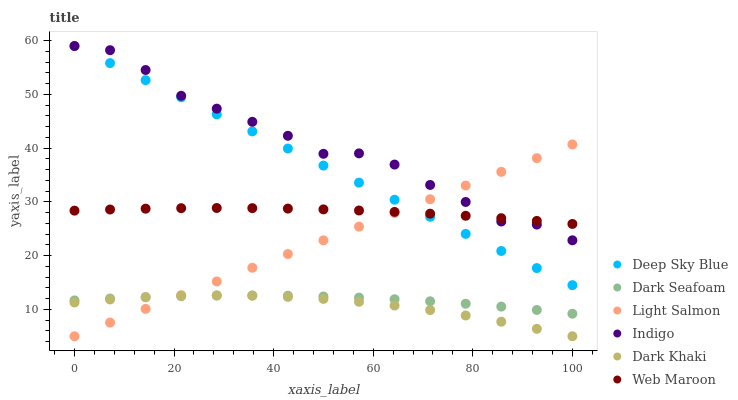Does Dark Khaki have the minimum area under the curve?
Answer yes or no. Yes. Does Indigo have the maximum area under the curve?
Answer yes or no. Yes. Does Web Maroon have the minimum area under the curve?
Answer yes or no. No. Does Web Maroon have the maximum area under the curve?
Answer yes or no. No. Is Light Salmon the smoothest?
Answer yes or no. Yes. Is Indigo the roughest?
Answer yes or no. Yes. Is Web Maroon the smoothest?
Answer yes or no. No. Is Web Maroon the roughest?
Answer yes or no. No. Does Light Salmon have the lowest value?
Answer yes or no. Yes. Does Indigo have the lowest value?
Answer yes or no. No. Does Deep Sky Blue have the highest value?
Answer yes or no. Yes. Does Web Maroon have the highest value?
Answer yes or no. No. Is Dark Seafoam less than Deep Sky Blue?
Answer yes or no. Yes. Is Deep Sky Blue greater than Dark Khaki?
Answer yes or no. Yes. Does Deep Sky Blue intersect Web Maroon?
Answer yes or no. Yes. Is Deep Sky Blue less than Web Maroon?
Answer yes or no. No. Is Deep Sky Blue greater than Web Maroon?
Answer yes or no. No. Does Dark Seafoam intersect Deep Sky Blue?
Answer yes or no. No. 